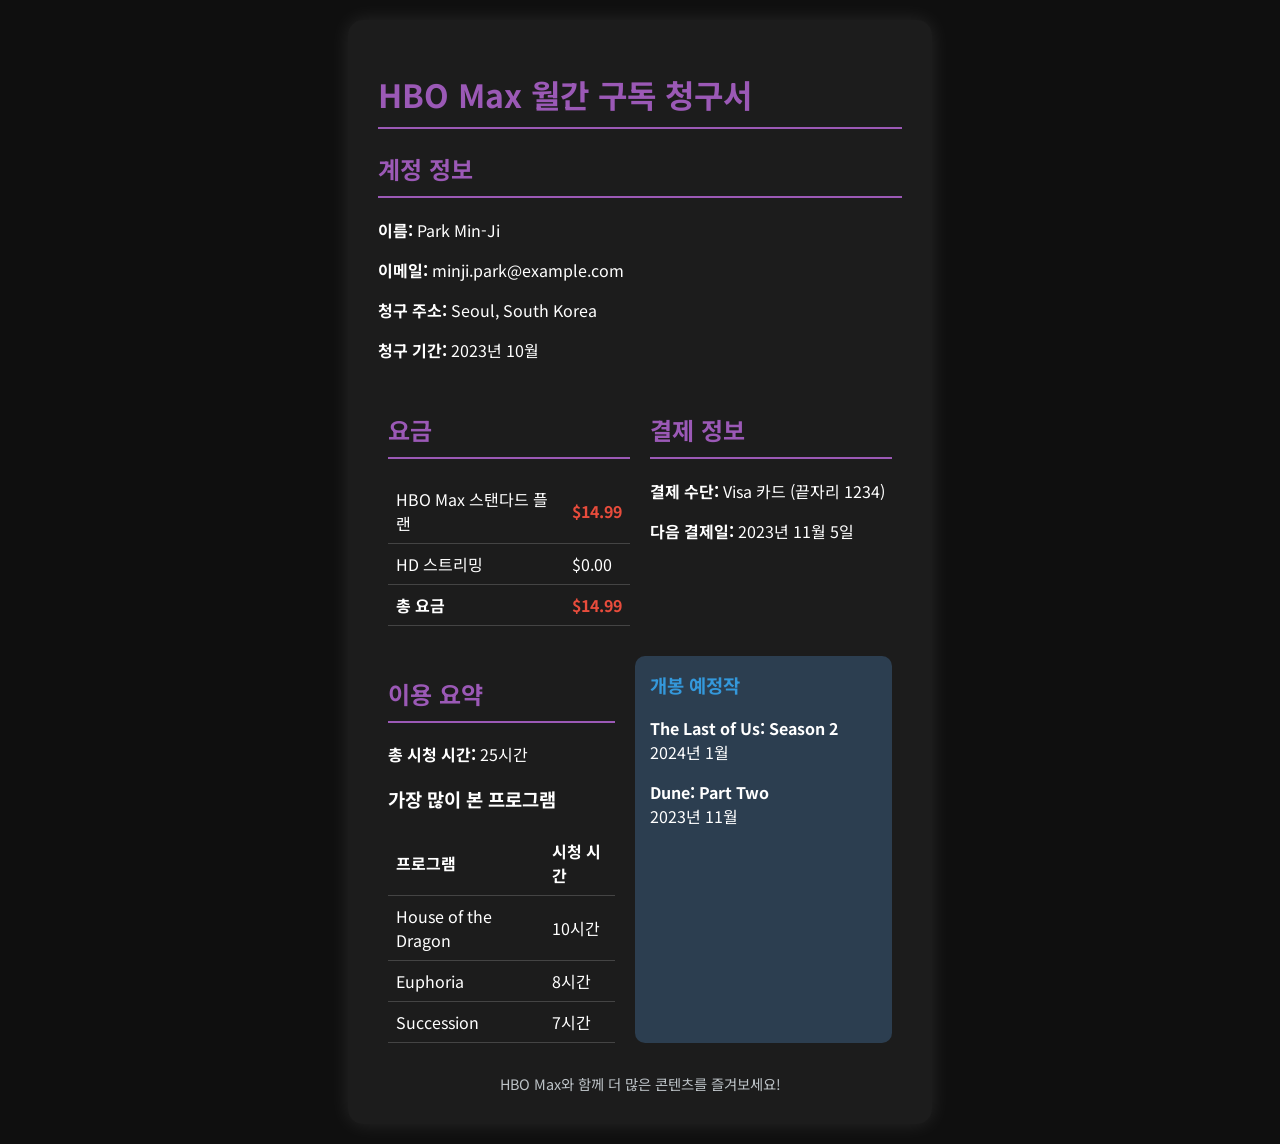What is the name of the account holder? The account holder's name is stated in the account information section as "Park Min-Ji."
Answer: Park Min-Ji What is the email address associated with the account? The email address can be found in the account information section, listed as "minji.park@example.com."
Answer: minji.park@example.com What is the total charge for the HBO Max subscription? The total charge is highlighted in the charges section as "$14.99."
Answer: $14.99 What payment method is used for the subscription? The payment method is mentioned in the charges section and is a "Visa 카드."
Answer: Visa 카드 How many hours of content were watched in total? The total viewing time is summarized as "25시간" in the usage summary section.
Answer: 25시간 What is the next payment date for the subscription? The next payment date is detailed in the payment information as "2023년 11월 5일."
Answer: 2023년 11월 5일 Which program was watched the most? The program with the highest view time is listed in the usage summary, specifically "House of the Dragon."
Answer: House of the Dragon How many hours did "Euphoria" get viewed? The viewing time for "Euphoria" is shown in the usage summary as "8시간."
Answer: 8시간 What is one of the upcoming releases mentioned? The document lists several upcoming releases, including "The Last of Us: Season 2."
Answer: The Last of Us: Season 2 